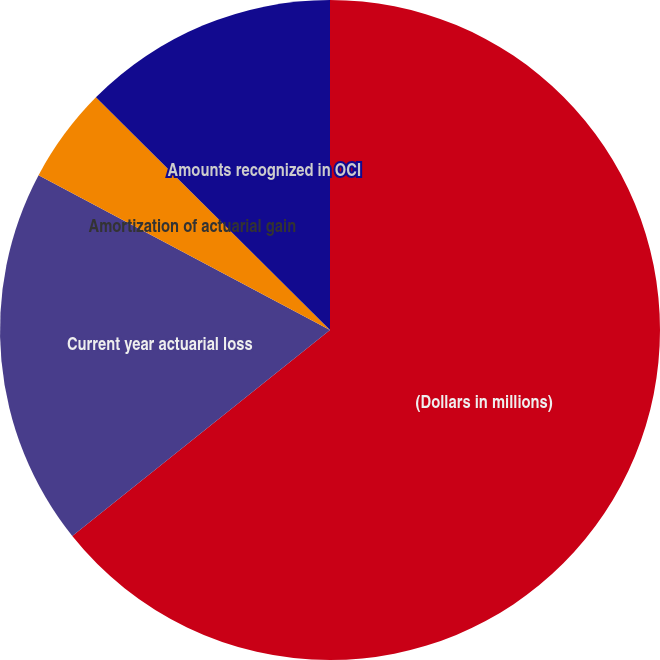Convert chart. <chart><loc_0><loc_0><loc_500><loc_500><pie_chart><fcel>(Dollars in millions)<fcel>Current year actuarial loss<fcel>Amortization of actuarial gain<fcel>Amounts recognized in OCI<nl><fcel>64.27%<fcel>18.51%<fcel>4.68%<fcel>12.55%<nl></chart> 